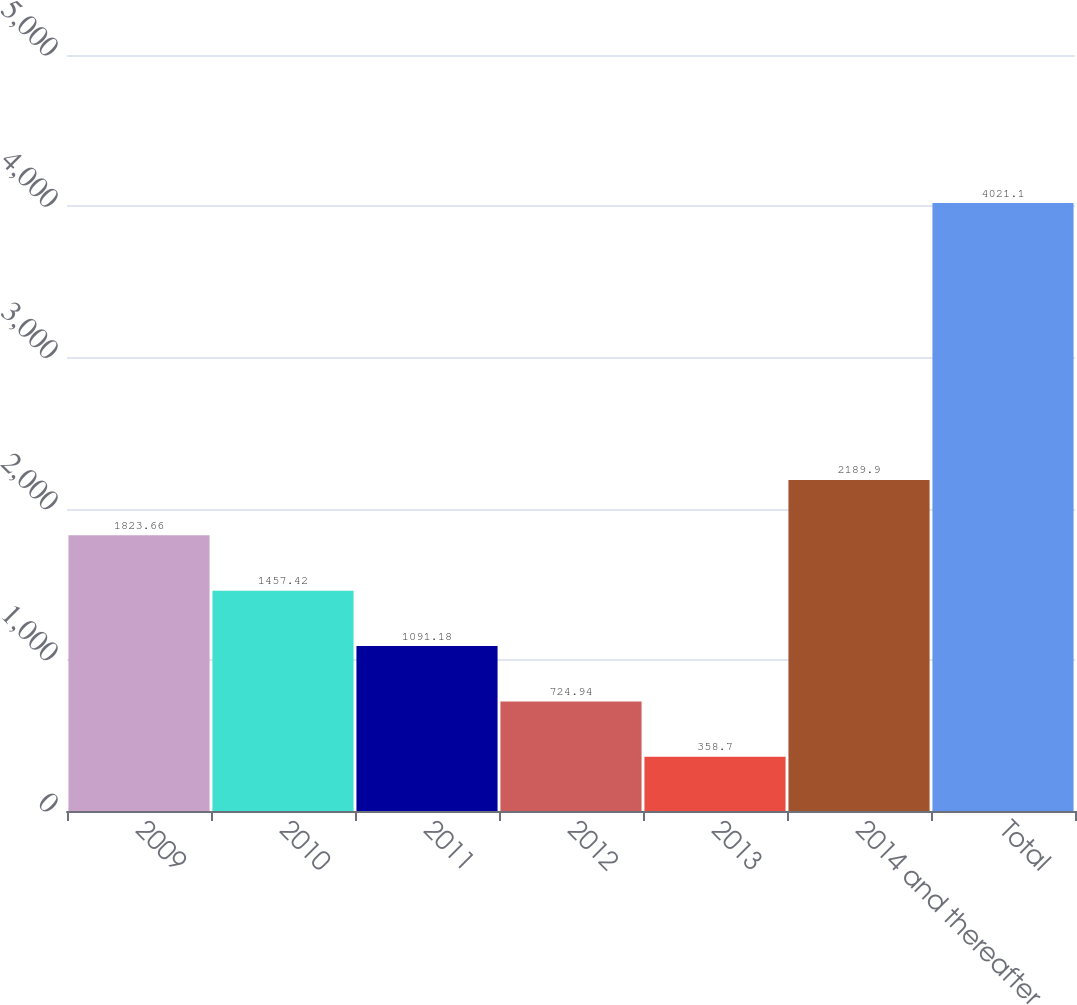<chart> <loc_0><loc_0><loc_500><loc_500><bar_chart><fcel>2009<fcel>2010<fcel>2011<fcel>2012<fcel>2013<fcel>2014 and thereafter<fcel>Total<nl><fcel>1823.66<fcel>1457.42<fcel>1091.18<fcel>724.94<fcel>358.7<fcel>2189.9<fcel>4021.1<nl></chart> 